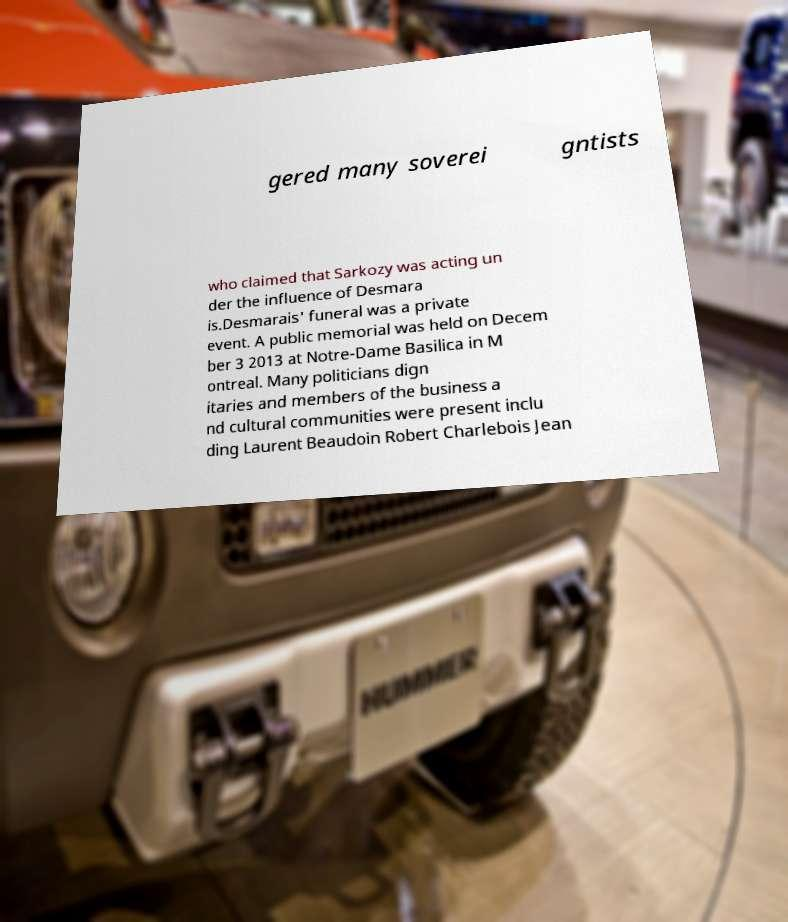For documentation purposes, I need the text within this image transcribed. Could you provide that? gered many soverei gntists who claimed that Sarkozy was acting un der the influence of Desmara is.Desmarais' funeral was a private event. A public memorial was held on Decem ber 3 2013 at Notre-Dame Basilica in M ontreal. Many politicians dign itaries and members of the business a nd cultural communities were present inclu ding Laurent Beaudoin Robert Charlebois Jean 